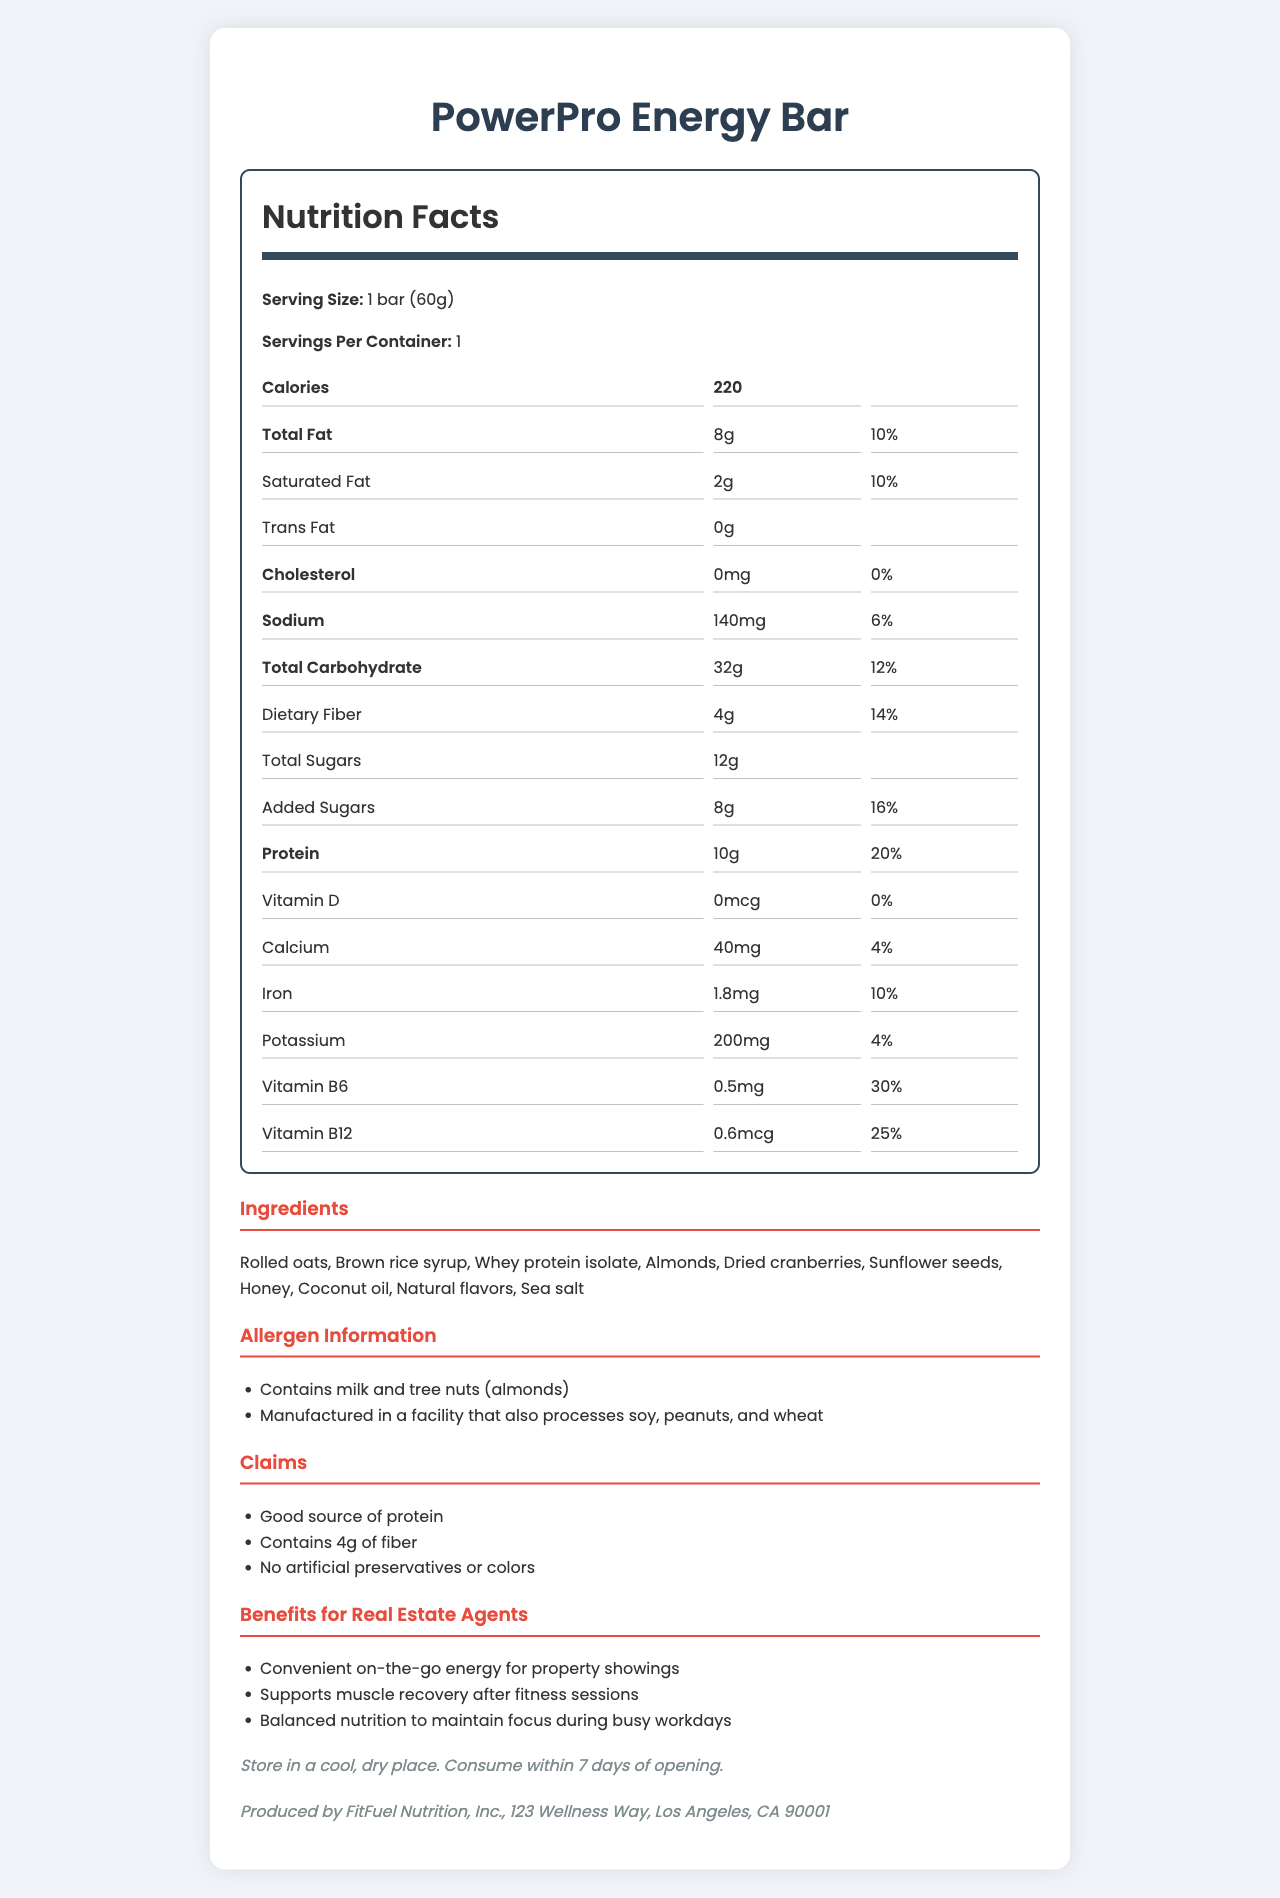what is the serving size of the PowerPro Energy Bar? The serving size is specified as "1 bar (60g)" in the Nutrition Facts section of the document.
Answer: 1 bar (60g) how many grams of protein are present in one serving of the PowerPro Energy Bar? The Nutrition Facts section lists 10g of protein per serving.
Answer: 10g what are the main benefits of this energy bar for real estate agents? The document contains a section "Benefits for Real Estate Agents" that lists these benefits specifically.
Answer: Convenient on-the-go energy for property showings, Supports muscle recovery after fitness sessions, Balanced nutrition to maintain focus during busy workdays what is the daily value percentage of saturated fat in one serving? The daily value percentage of saturated fat is listed as 10% in the Nutrition Facts section.
Answer: 10% how much added sugar does the PowerPro Energy Bar contain? The Nutrition Facts section specifies that the energy bar contains 8g of added sugars.
Answer: 8g which of the following is NOT an ingredient in the PowerPro Energy Bar? A. Rolled oats B. Almond butter C. Honey D. Coconut oil The list of ingredients includes Rolled oats, Honey, and Coconut oil, but it does not mention Almond butter.
Answer: B what percentage of the daily value of Vitamin B6 does the PowerPro Energy Bar provide? A. 10% B. 20% C. 25% D. 30% The document specifies that the energy bar provides 30% of the daily value of Vitamin B6.
Answer: D does the PowerPro Energy Bar contain any trans fat? The Nutrition Facts section lists the trans fat content as "0g", indicating that there are no trans fats.
Answer: No summarize the main features and nutritional information of the PowerPro Energy Bar. This summary combines details from various sections, including serving size, calories, macronutrients, vitamins, ingredients, and storage instructions, to provide a comprehensive overview of the document.
Answer: The PowerPro Energy Bar is a convenient and nutritious snack ideal for busy professionals, including real estate agents. It contains 220 calories per serving with 10g of protein, 8g of total fat, and 32g of carbohydrates. The bar is a good source of fiber, protein, Vitamin B6, and Vitamin B12, and has no artificial preservatives or colors. It includes ingredients such as rolled oats, whey protein isolate, and almonds, and should be stored in a cool, dry place. can I consume the PowerPro Energy Bar if I am allergic to peanuts? The document states that it is manufactured in a facility that also processes peanuts, but it does not provide enough information to determine if cross-contamination is a risk.
Answer: Cannot be determined what is the manufacturer of the PowerPro Energy Bar? The manufacturer information section states that the bar is produced by FitFuel Nutrition, Inc.
Answer: FitFuel Nutrition, Inc. how much dietary fiber does one serving of the PowerPro Energy Bar contain? The Nutrition Facts section specifies that the dietary fiber content per serving is 4g.
Answer: 4g 